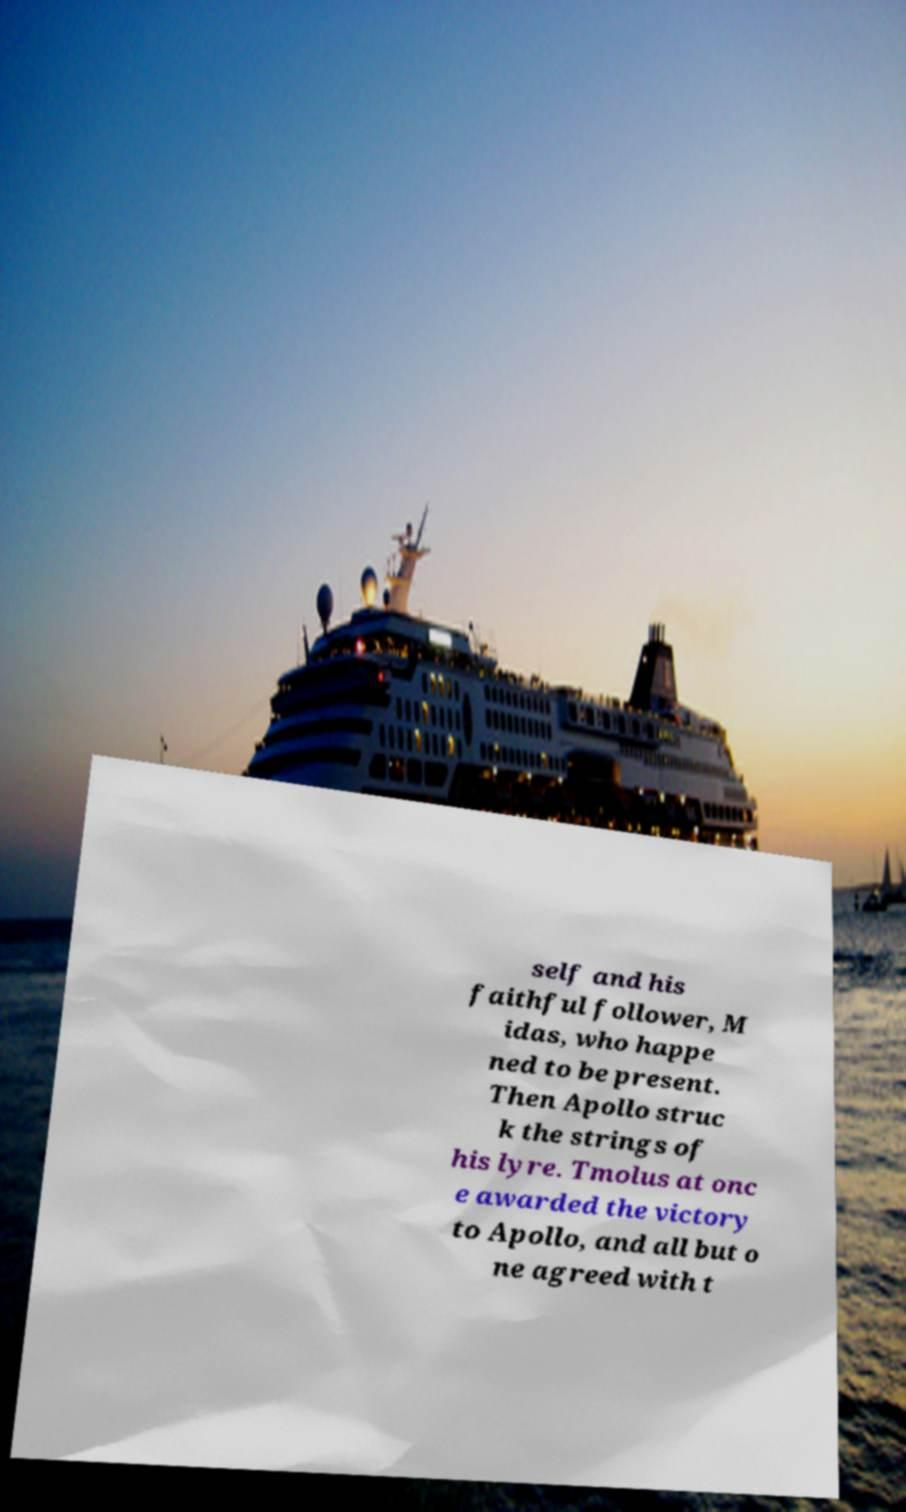Please read and relay the text visible in this image. What does it say? self and his faithful follower, M idas, who happe ned to be present. Then Apollo struc k the strings of his lyre. Tmolus at onc e awarded the victory to Apollo, and all but o ne agreed with t 